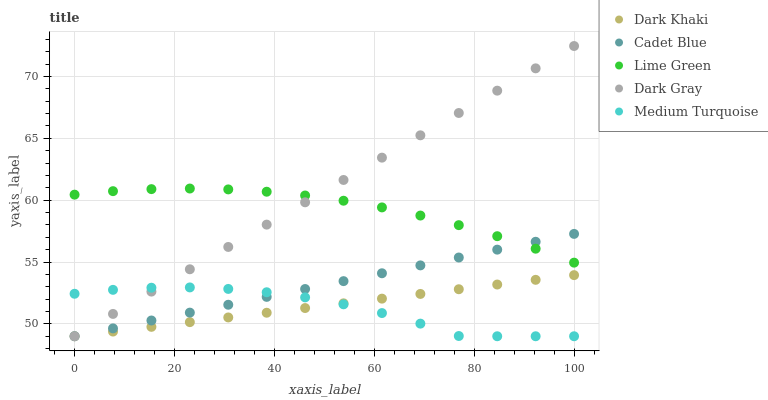Does Medium Turquoise have the minimum area under the curve?
Answer yes or no. Yes. Does Dark Gray have the maximum area under the curve?
Answer yes or no. Yes. Does Cadet Blue have the minimum area under the curve?
Answer yes or no. No. Does Cadet Blue have the maximum area under the curve?
Answer yes or no. No. Is Dark Gray the smoothest?
Answer yes or no. Yes. Is Medium Turquoise the roughest?
Answer yes or no. Yes. Is Cadet Blue the smoothest?
Answer yes or no. No. Is Cadet Blue the roughest?
Answer yes or no. No. Does Dark Khaki have the lowest value?
Answer yes or no. Yes. Does Lime Green have the lowest value?
Answer yes or no. No. Does Dark Gray have the highest value?
Answer yes or no. Yes. Does Cadet Blue have the highest value?
Answer yes or no. No. Is Dark Khaki less than Lime Green?
Answer yes or no. Yes. Is Lime Green greater than Dark Khaki?
Answer yes or no. Yes. Does Dark Gray intersect Dark Khaki?
Answer yes or no. Yes. Is Dark Gray less than Dark Khaki?
Answer yes or no. No. Is Dark Gray greater than Dark Khaki?
Answer yes or no. No. Does Dark Khaki intersect Lime Green?
Answer yes or no. No. 